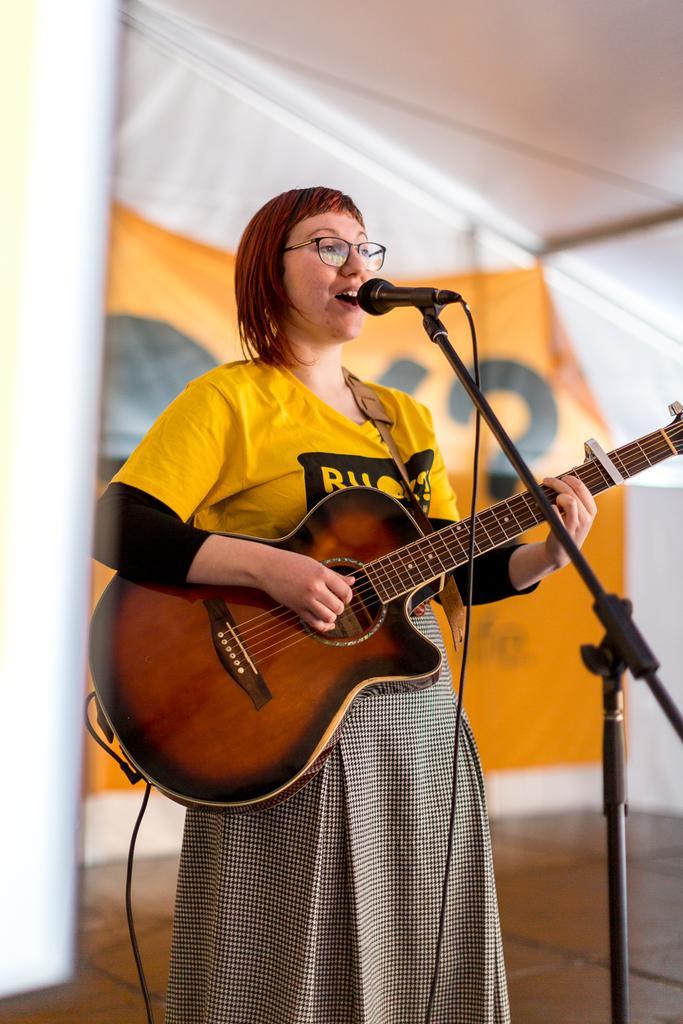How would you summarize this image in a sentence or two? In the image in the center there is a woman she is singing which we can see on her face,and she is playing guitar and back of her there is a banner. 